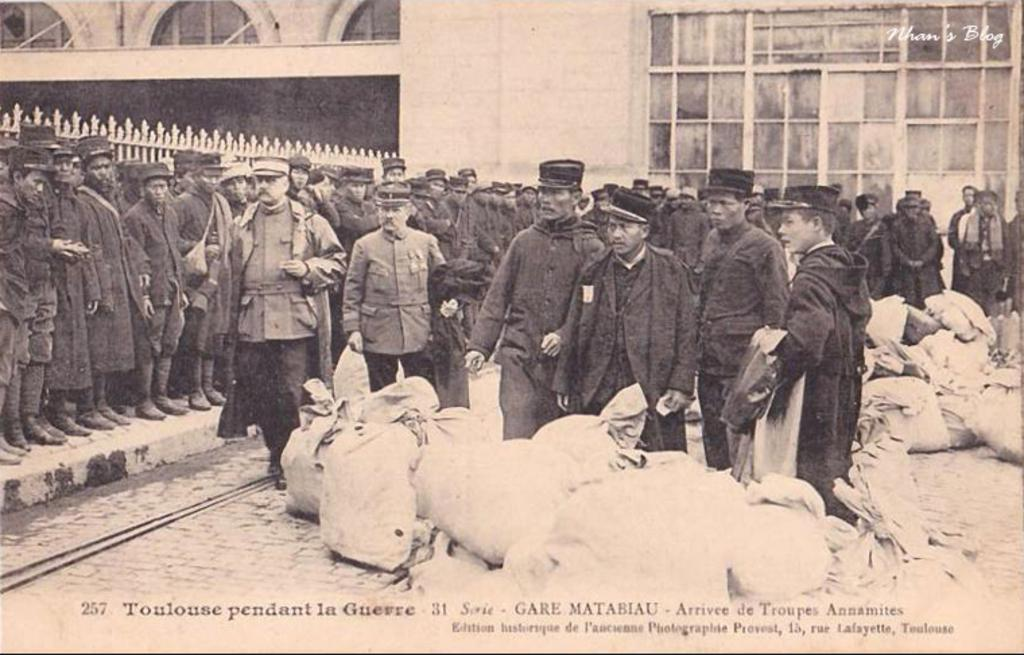How many people are in the group in the image? There is a group of persons in the image, but the exact number cannot be determined from the provided facts. What are the bags in front of the persons used for? The purpose of the bags in front of the persons cannot be determined from the provided facts. What is the background of the image? There is a fencing and a building visible behind the persons in the image. What is written at the bottom of the image? There is text at the bottom of the image, but its content cannot be determined from the provided facts. What type of bike is parked next to the hospital in the image? There is no bike or hospital present in the image. What organization is responsible for the text at the bottom of the image? The organization responsible for the text at the bottom of the image cannot be determined from the provided facts. 